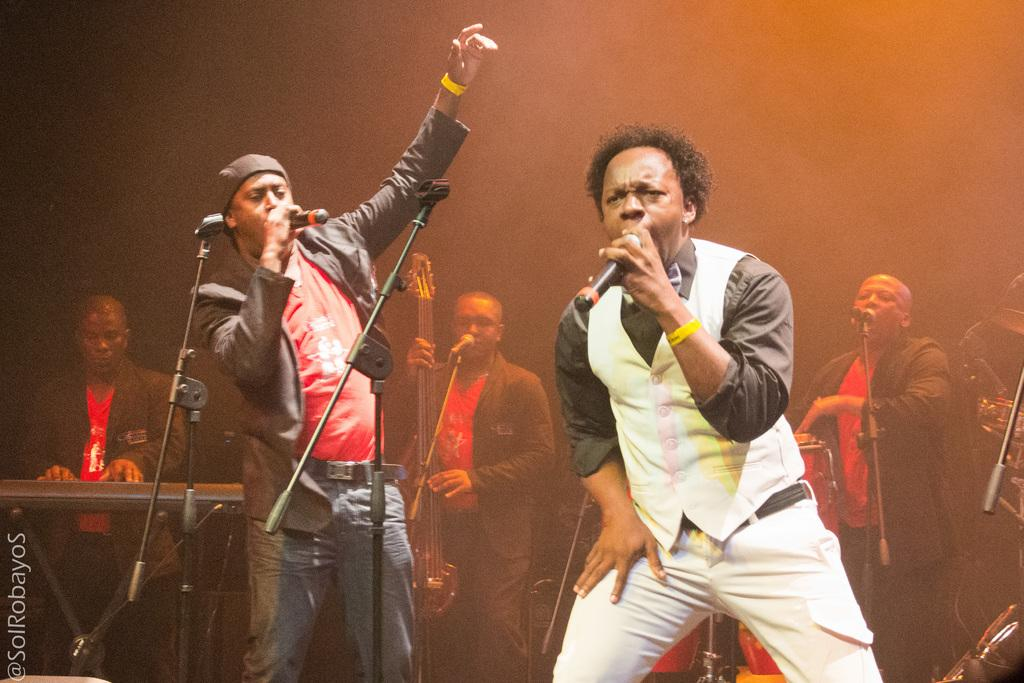What is happening in the image? There is a group of persons playing musical instruments in the image. Can you describe the people in the foreground of the image? There are two persons at the foreground of the image who are singing. What type of wire is being used by the singers to hold their microphones in the image? There are no microphones or wires visible in the image; the singers are singing without any apparent equipment. 